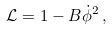<formula> <loc_0><loc_0><loc_500><loc_500>\mathcal { L } = 1 - B \dot { \phi } ^ { 2 } \, ,</formula> 